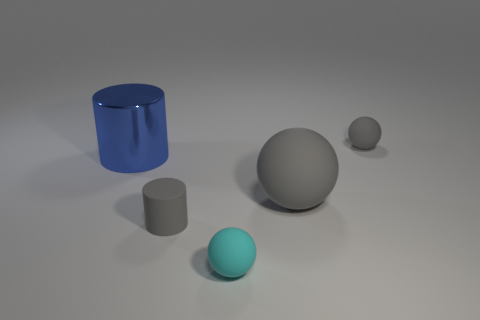Is the color of the big shiny cylinder the same as the small thing behind the small cylinder?
Offer a very short reply. No. Are there fewer blue metal cylinders than gray objects?
Make the answer very short. Yes. Is the number of gray matte spheres that are in front of the big sphere greater than the number of gray rubber cylinders on the right side of the large cylinder?
Make the answer very short. No. Is the material of the large gray object the same as the large cylinder?
Offer a terse response. No. How many tiny rubber objects are left of the tiny gray object that is behind the small gray rubber cylinder?
Your response must be concise. 2. There is a matte ball that is behind the shiny cylinder; is its color the same as the small cylinder?
Offer a very short reply. Yes. How many things are big cyan rubber spheres or spheres that are in front of the rubber cylinder?
Give a very brief answer. 1. Is the shape of the tiny rubber thing that is left of the cyan matte thing the same as the tiny object that is behind the big blue object?
Keep it short and to the point. No. Are there any other things that have the same color as the big ball?
Provide a succinct answer. Yes. The cyan object that is made of the same material as the tiny gray sphere is what shape?
Provide a succinct answer. Sphere. 